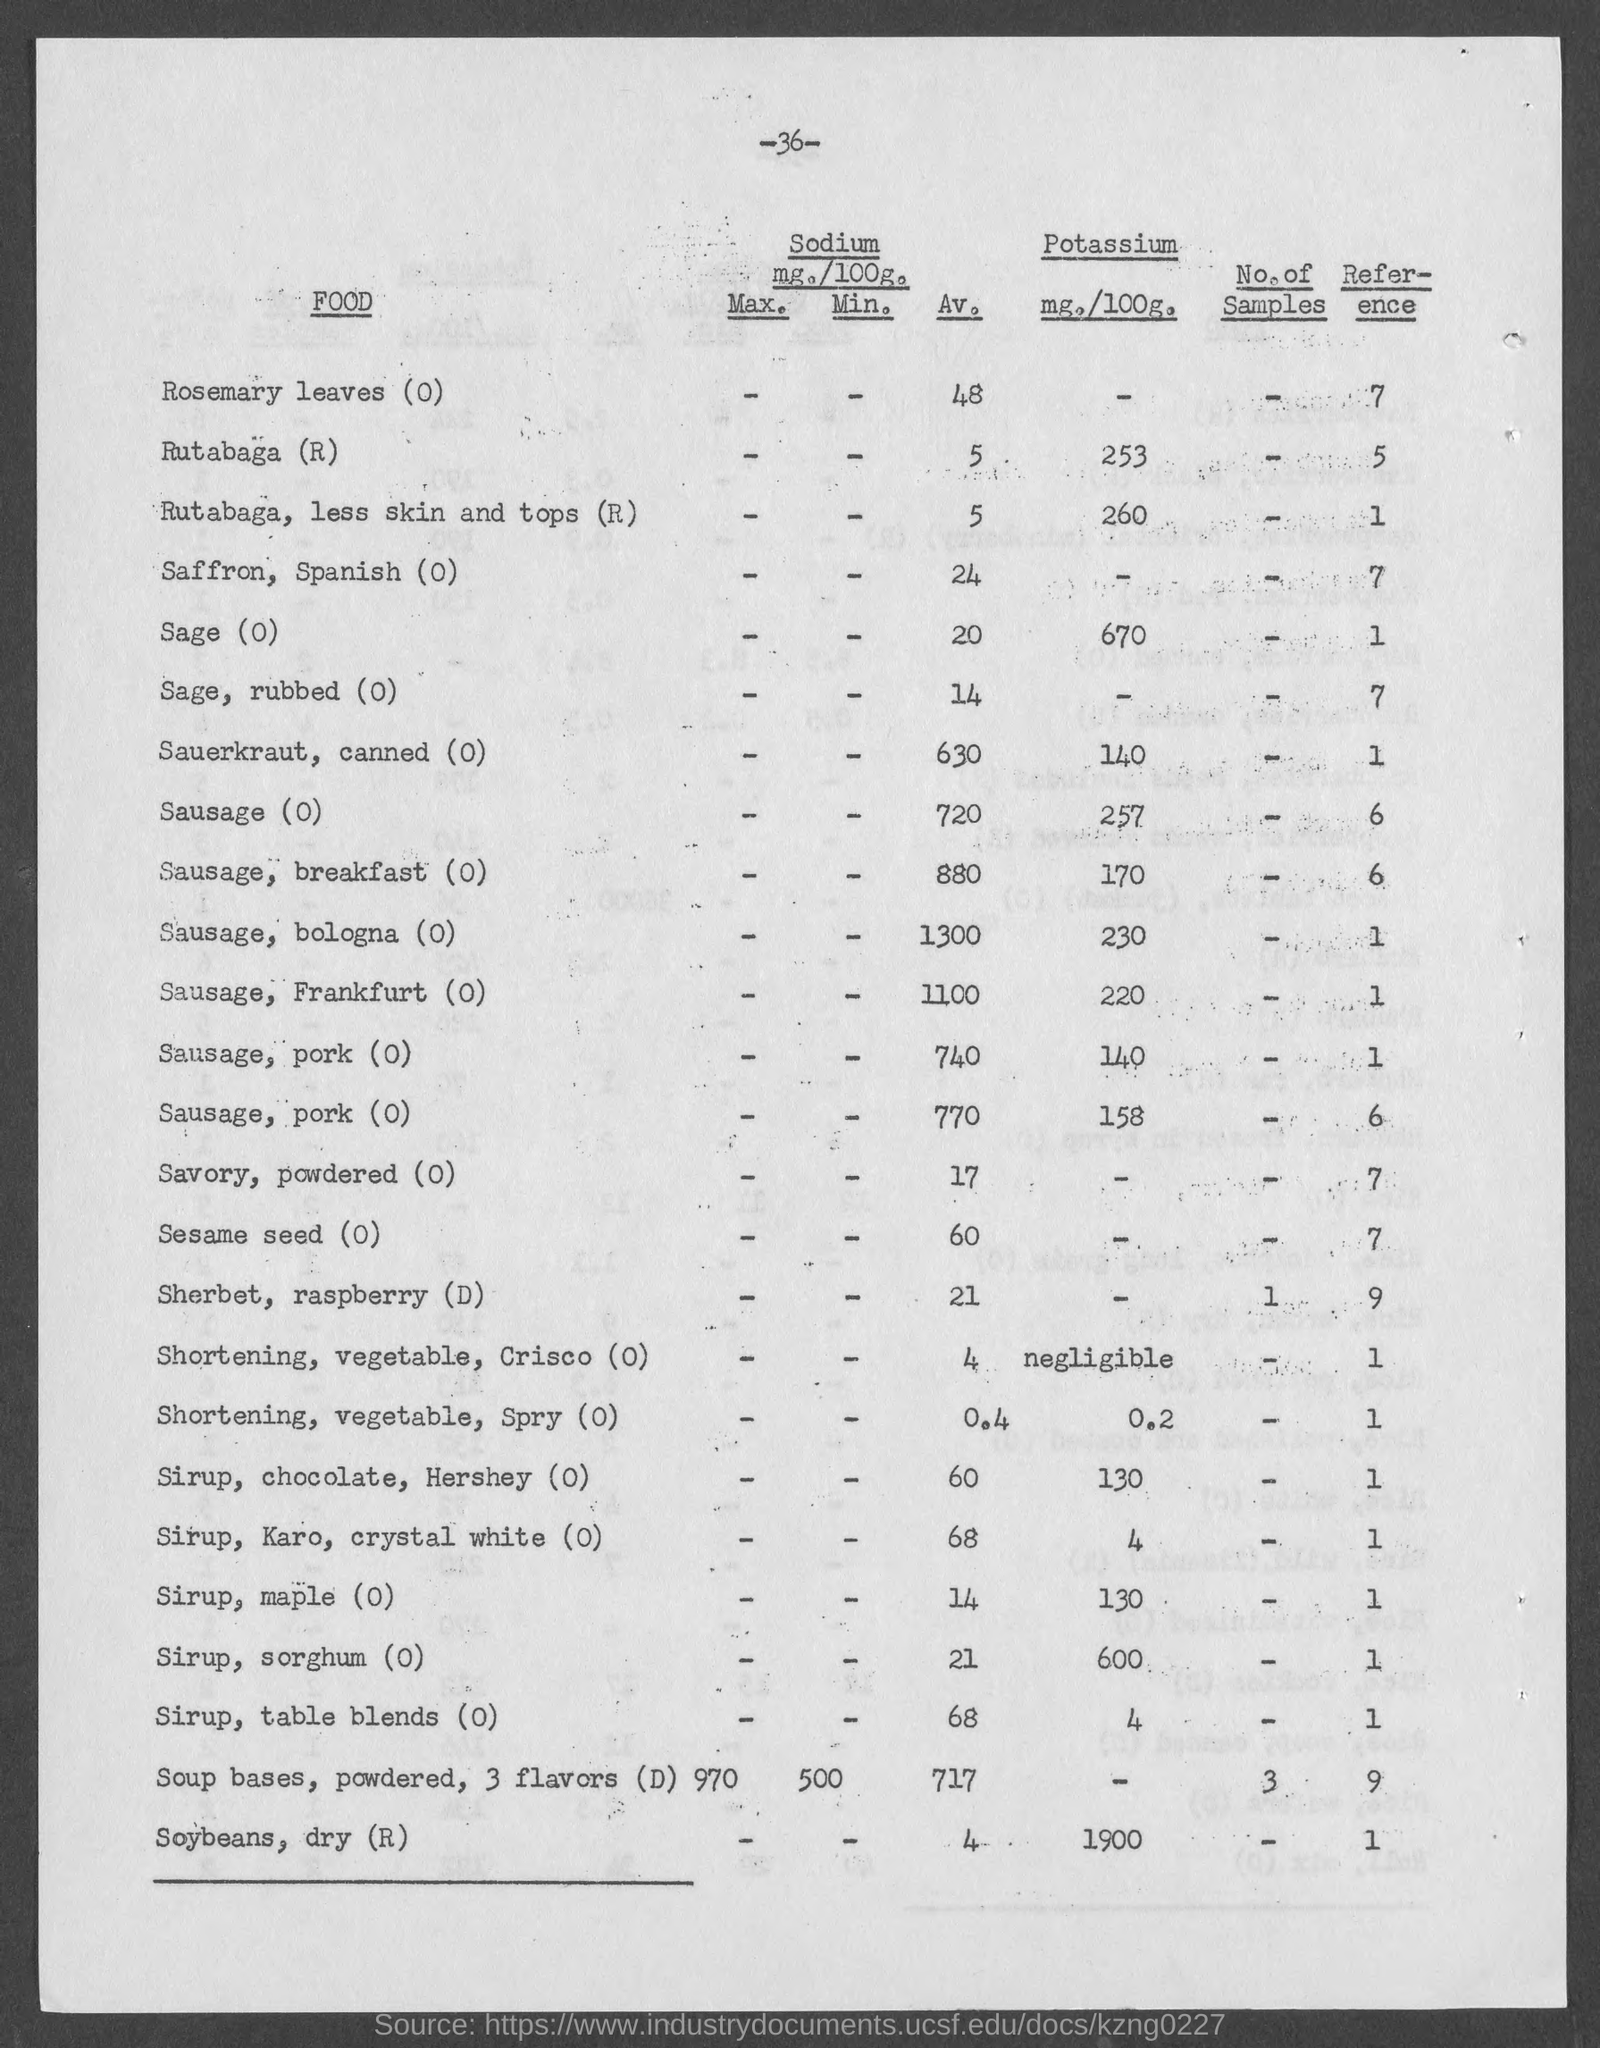Specify some key components in this picture. The reference number for Sage(O) is 1.. I would like to know the reference number for Sausage, Breakfast (O), please. On the top of the page, there is a number. The number is 36. What is the reference number for rutabaga, less skin and tops (R)? The reference number for Sauerkraut, canned (O) is 1.. 